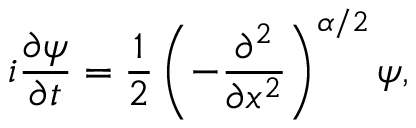<formula> <loc_0><loc_0><loc_500><loc_500>i \frac { \partial \psi } { \partial t } = \frac { 1 } { 2 } \left ( - \frac { \partial ^ { 2 } } { \partial x ^ { 2 } } \right ) ^ { \alpha / 2 } \psi ,</formula> 